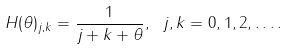<formula> <loc_0><loc_0><loc_500><loc_500>H ( \theta ) _ { j , k } = \frac { 1 } { j + k + \theta } , \ j , k = 0 , 1 , 2 , \dots .</formula> 